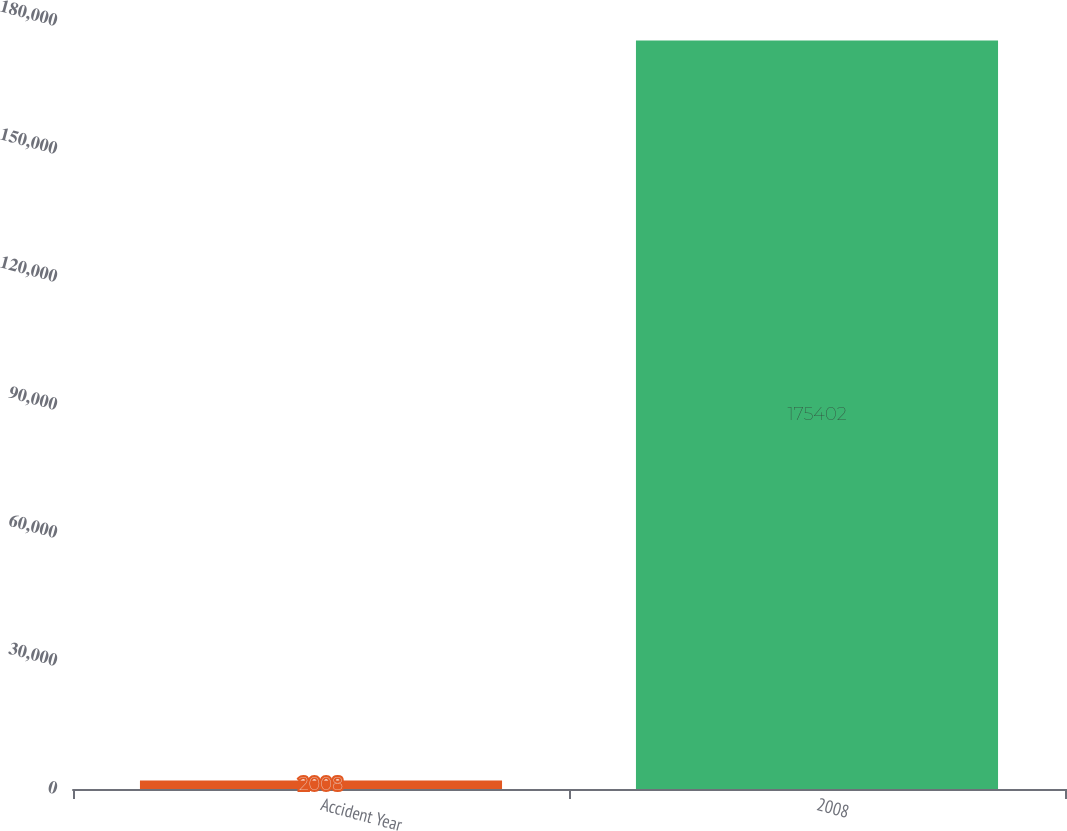Convert chart. <chart><loc_0><loc_0><loc_500><loc_500><bar_chart><fcel>Accident Year<fcel>2008<nl><fcel>2008<fcel>175402<nl></chart> 